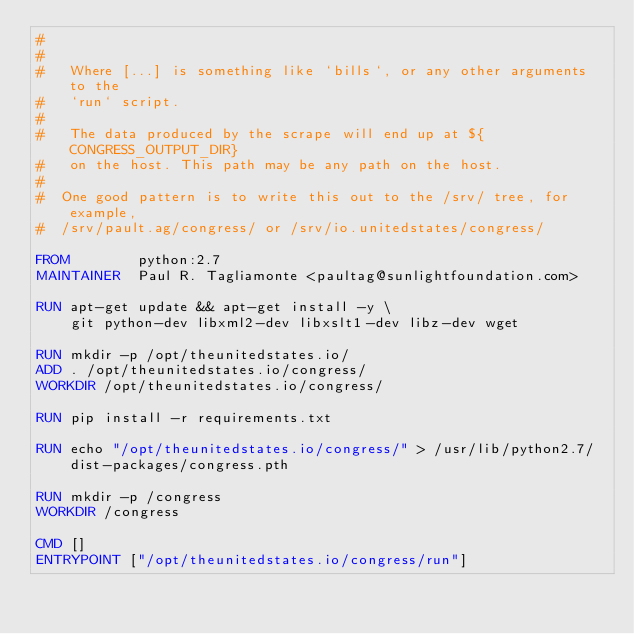Convert code to text. <code><loc_0><loc_0><loc_500><loc_500><_Dockerfile_>#
#
#   Where [...] is something like `bills`, or any other arguments to the
#   `run` script.
#
#   The data produced by the scrape will end up at ${CONGRESS_OUTPUT_DIR}
#   on the host. This path may be any path on the host.
#
#  One good pattern is to write this out to the /srv/ tree, for example,
#  /srv/pault.ag/congress/ or /srv/io.unitedstates/congress/

FROM        python:2.7
MAINTAINER  Paul R. Tagliamonte <paultag@sunlightfoundation.com>

RUN apt-get update && apt-get install -y \
    git python-dev libxml2-dev libxslt1-dev libz-dev wget

RUN mkdir -p /opt/theunitedstates.io/
ADD . /opt/theunitedstates.io/congress/
WORKDIR /opt/theunitedstates.io/congress/

RUN pip install -r requirements.txt

RUN echo "/opt/theunitedstates.io/congress/" > /usr/lib/python2.7/dist-packages/congress.pth

RUN mkdir -p /congress
WORKDIR /congress

CMD []
ENTRYPOINT ["/opt/theunitedstates.io/congress/run"]
</code> 